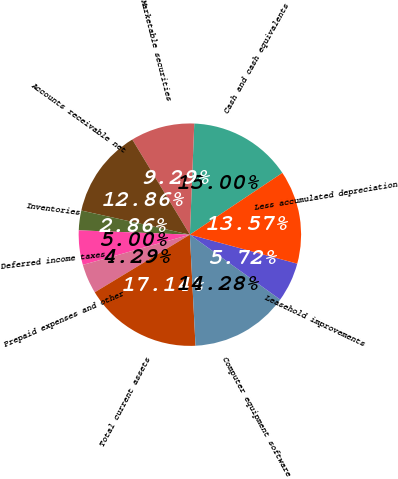<chart> <loc_0><loc_0><loc_500><loc_500><pie_chart><fcel>Cash and cash equivalents<fcel>Marketable securities<fcel>Accounts receivable net<fcel>Inventories<fcel>Deferred income taxes<fcel>Prepaid expenses and other<fcel>Total current assets<fcel>Computer equipment software<fcel>Leasehold improvements<fcel>Less accumulated depreciation<nl><fcel>15.0%<fcel>9.29%<fcel>12.86%<fcel>2.86%<fcel>5.0%<fcel>4.29%<fcel>17.14%<fcel>14.28%<fcel>5.72%<fcel>13.57%<nl></chart> 